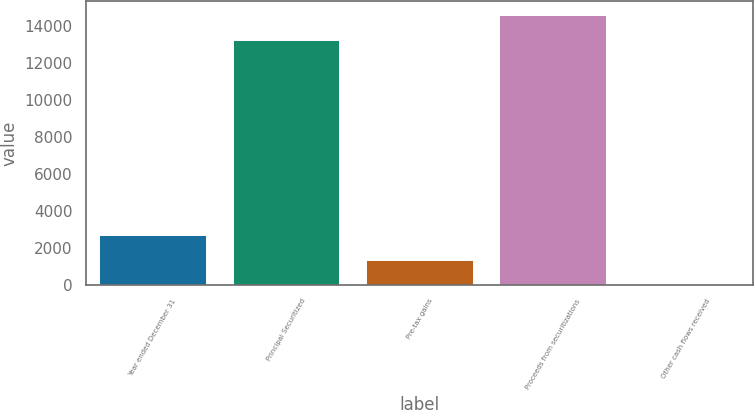Convert chart. <chart><loc_0><loc_0><loc_500><loc_500><bar_chart><fcel>Year ended December 31<fcel>Principal Securitized<fcel>Pre-tax gains<fcel>Proceeds from securitizations<fcel>Other cash flows received<nl><fcel>2709.6<fcel>13270<fcel>1355.8<fcel>14623.8<fcel>2<nl></chart> 